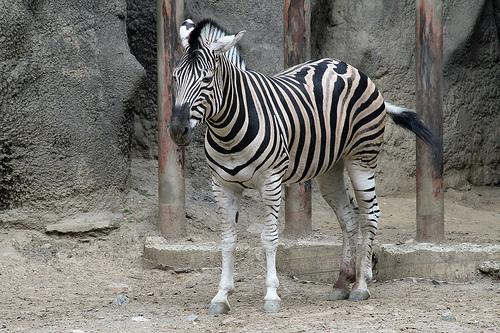Question: when is this photo taken?
Choices:
A. At dawn.
B. At dusk.
C. Daytime.
D. At night.
Answer with the letter. Answer: C Question: what kind of animal is this?
Choices:
A. Zebra.
B. Elephant.
C. Tiger.
D. Hippo.
Answer with the letter. Answer: A 